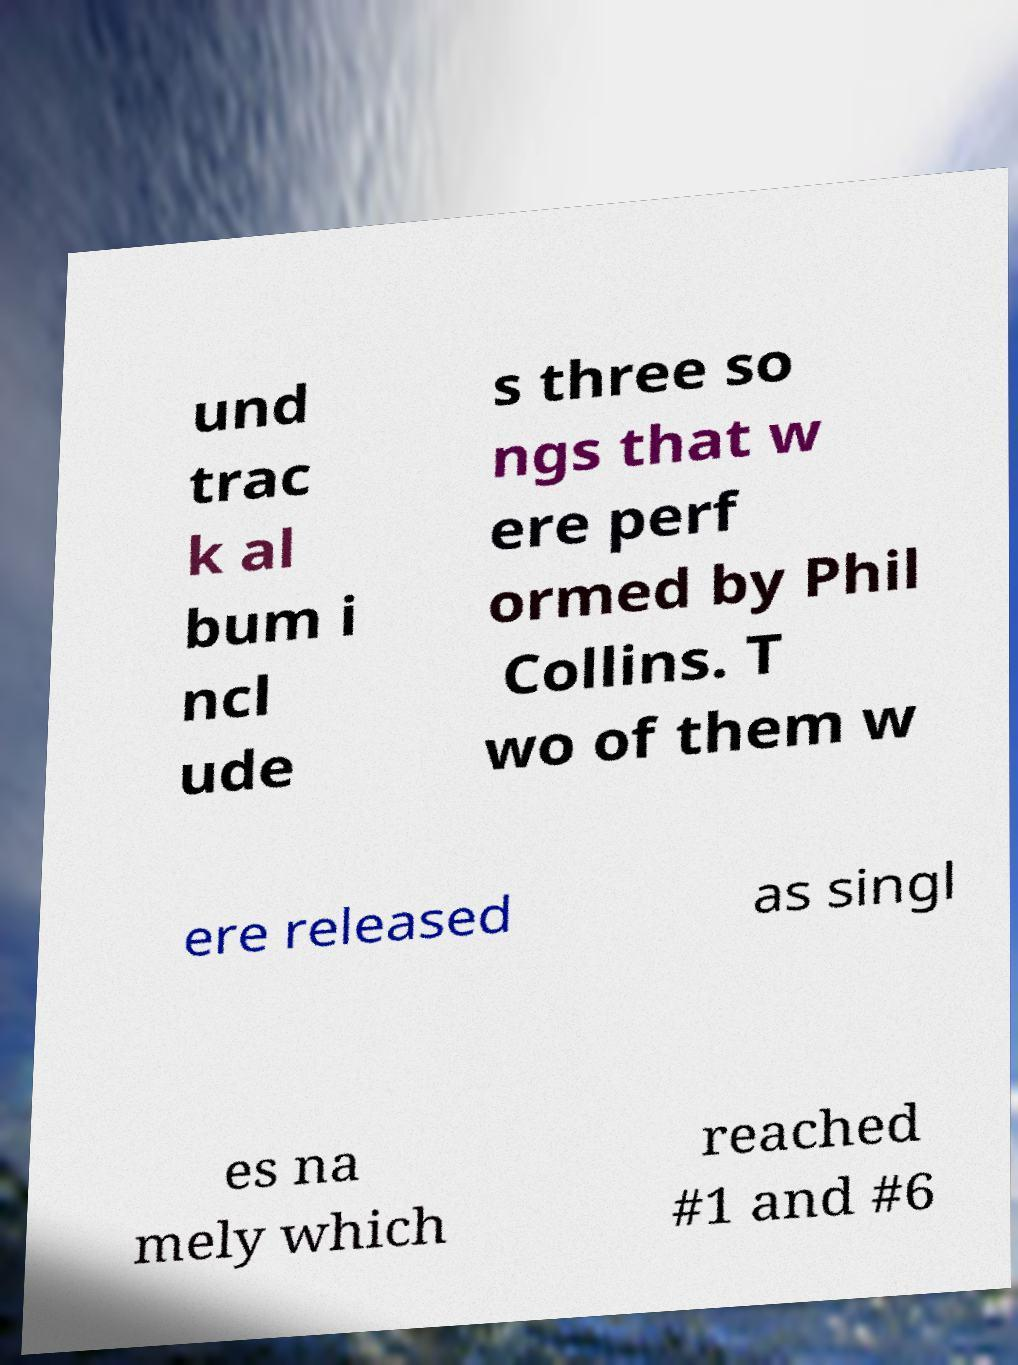What messages or text are displayed in this image? I need them in a readable, typed format. und trac k al bum i ncl ude s three so ngs that w ere perf ormed by Phil Collins. T wo of them w ere released as singl es na mely which reached #1 and #6 